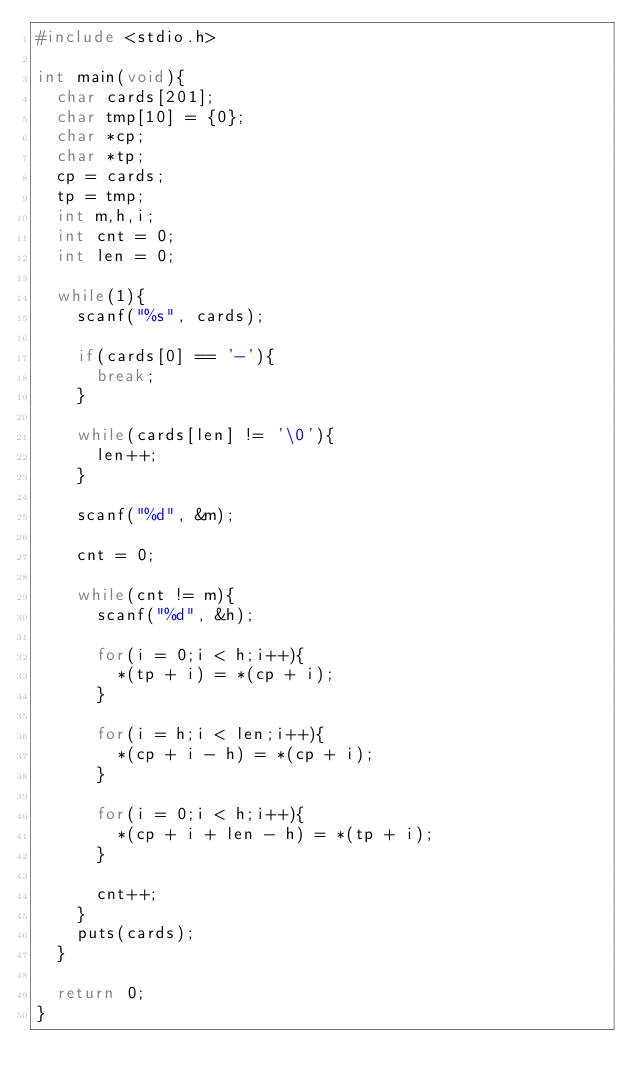Convert code to text. <code><loc_0><loc_0><loc_500><loc_500><_C_>#include <stdio.h>

int main(void){
	char cards[201];
	char tmp[10] = {0};
	char *cp;
	char *tp;
	cp = cards;
	tp = tmp;
	int m,h,i;
	int cnt = 0;
	int len = 0;

	while(1){
		scanf("%s", cards);

		if(cards[0] == '-'){
			break;
		}

		while(cards[len] != '\0'){
			len++;
		}

		scanf("%d", &m);

		cnt = 0;

		while(cnt != m){
			scanf("%d", &h);

			for(i = 0;i < h;i++){
				*(tp + i) = *(cp + i);
			}

			for(i = h;i < len;i++){
				*(cp + i - h) = *(cp + i);
			}

			for(i = 0;i < h;i++){
				*(cp + i + len - h) = *(tp + i);
			}

			cnt++;
		}
		puts(cards);
	}

	return 0;
}</code> 